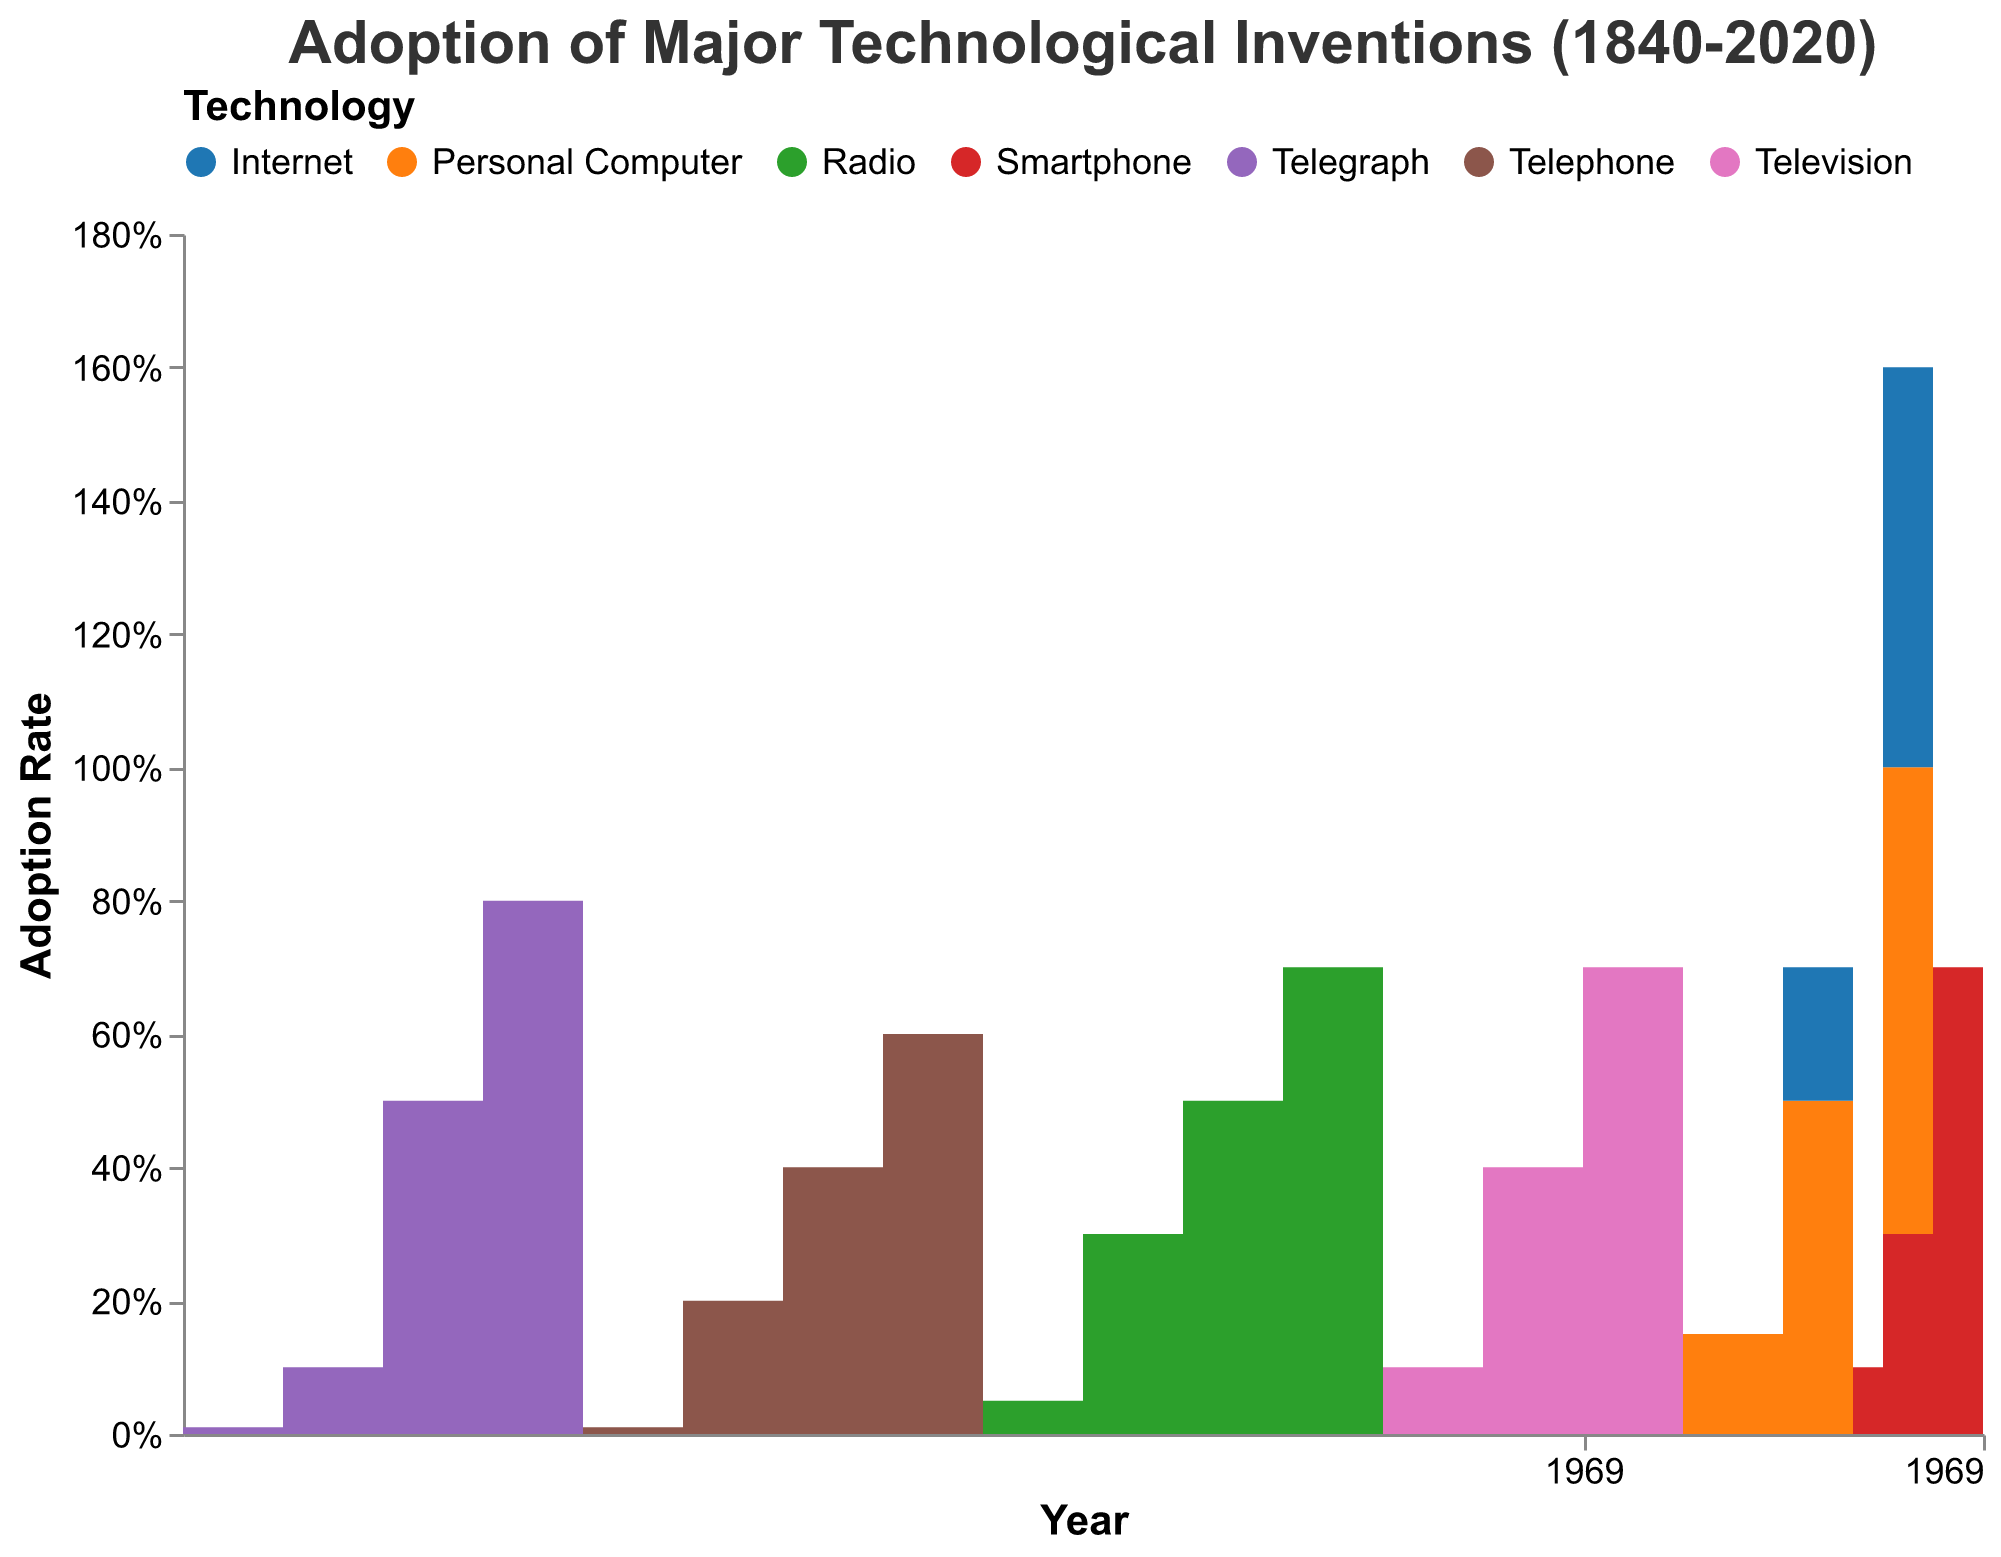Which technology had the highest adoption rate in 2020? Check the data for 2020 and find the technology with the highest adoption rate, which is the Internet at 0.90.
Answer: Internet How many technologies are considered in this chart? Count each unique technology listed in the data values: Telegraph, Telephone, Radio, Television, Personal Computer, Internet, and Smartphone. There are 7 distinct technologies shown.
Answer: 7 Which technology had the slowest initial adoption rate? To determine this, look at the starting adoption rate for each technology. The Telegraph starts with 0.01 in 1840, the Telephone with 0.01 in 1880, and others started with values higher than 0.01. Both the Telegraph and Telephone have an initial adoption rate of 0.01; however, given the specific data's starting year for each technology, both can be considered to have slow starts.
Answer: Telegraph/Telephone By how much did the adoption rate of Telephones increase from 1880 to 1910? Check the adoption rates of Telephones in 1880 and 1910. In 1880, it was 0.01, and in 1910, it was 0.60. Subtract 0.01 from 0.60: 0.60 - 0.01 = 0.59.
Answer: 0.59 Between which years did the Smartphone have the highest rate of adoption increase? Review the data for Smartphones and calculate the differences in adoption rates over each period: from 2007 to 2010, the rate increased by 0.20 (0.30 - 0.10); from 2010 to 2015, it increased by 0.40 (0.70 - 0.30); from 2015 to 2020, it increased by 0.15 (0.85 - 0.70). The highest increase is from 2010 to 2015.
Answer: 2010 to 2015 Which technology's adoption rate first reached 70% and in which year? Check the adoption rates nearing or exceeding 70% for each technology category. The Radio reached 70% first in 1950.
Answer: Radio, 1950 In what year did Personal Computers reach the same adoption rate as Radio in 1940? The adoption rate of Radio in 1940 was 0.50. Find the year for Personal Computers reaching the same rate; in 2000, the adoption rate for Personal Computers was also 0.50.
Answer: 2000 Compare the adoption rates of Television and Radio in 1970. Which had a higher rate? Look at the adoption rates for both Television and Radio in 1970. Television had a rate of 0.40 and Radio had stopped increasing by 1970 at 0.70. Thus, Radio had a higher rate.
Answer: Radio What can be inferred about the adoption rate speed from Telegraph compared to that of the Internet? Compare the growth span of their respective adoption rates. The Telegraph reached 80% over roughly 30 years (1840-1870), while the Internet went from 20% in 2000 to 90% in 2020 (20 years). The Internet adoption rate increased more rapidly.
Answer: Internet increased more rapidly How did the adoption rates for Radio and Television compare in 1960? Analyze the given rates for Radio and Television in 1960. Radio had 70% adoption, and Television had 10%. Thus, Radio's adoption rate was significantly higher.
Answer: Radio 